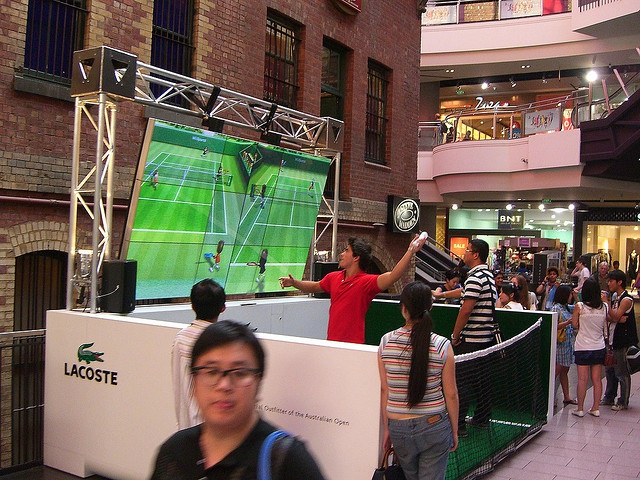Describe the objects in this image and their specific colors. I can see tv in brown, green, lightgreen, turquoise, and black tones, people in brown, black, and maroon tones, people in brown, black, gray, and maroon tones, people in brown, black, maroon, gray, and lightgray tones, and people in brown, maroon, and black tones in this image. 